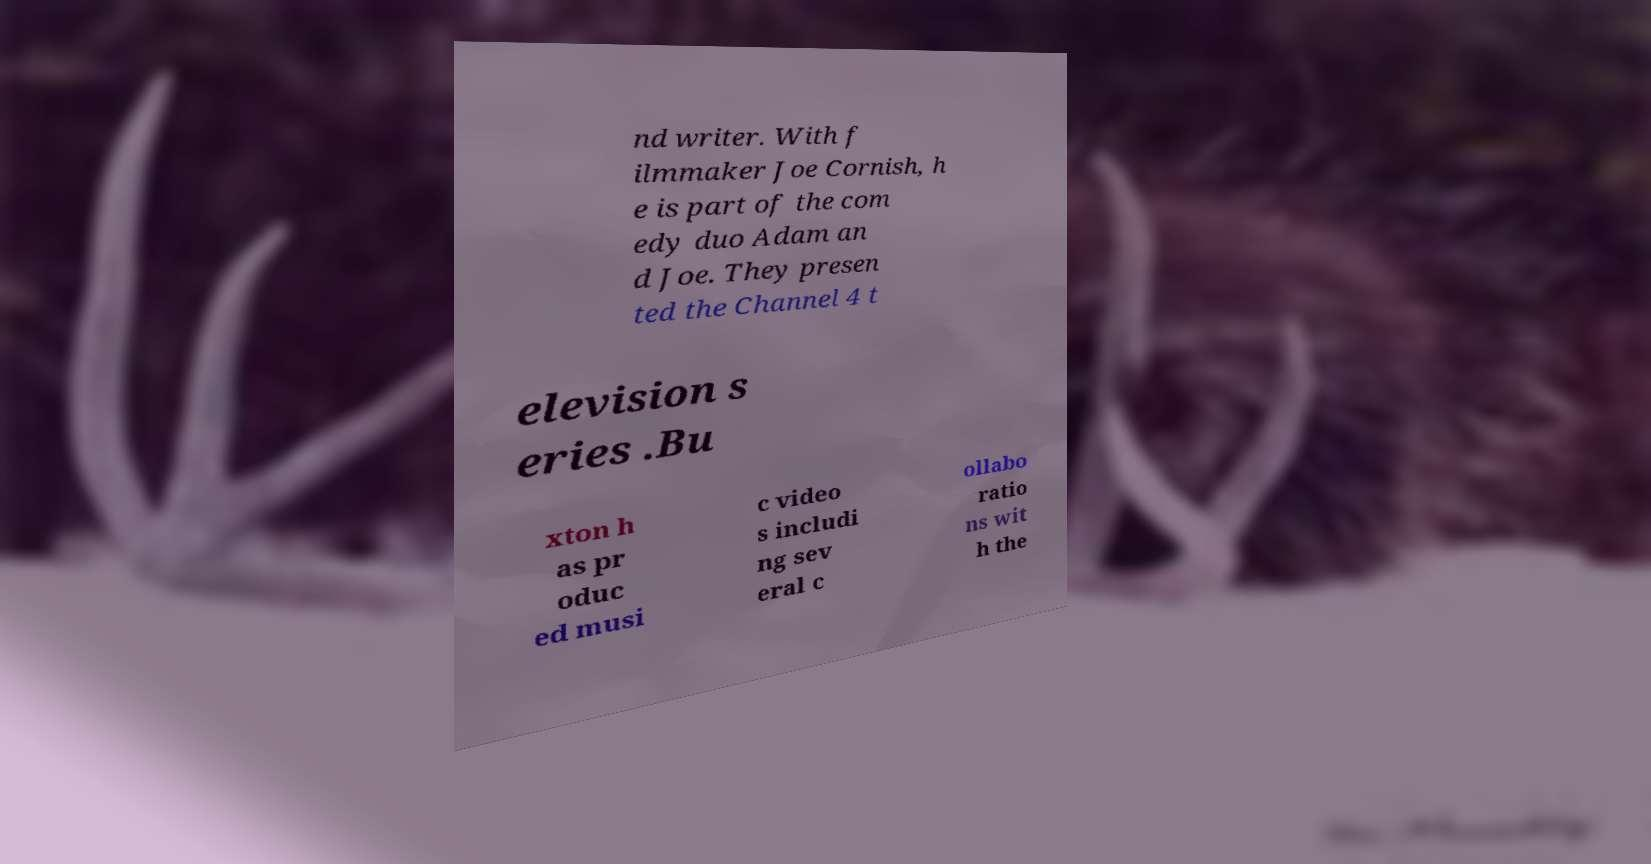I need the written content from this picture converted into text. Can you do that? nd writer. With f ilmmaker Joe Cornish, h e is part of the com edy duo Adam an d Joe. They presen ted the Channel 4 t elevision s eries .Bu xton h as pr oduc ed musi c video s includi ng sev eral c ollabo ratio ns wit h the 